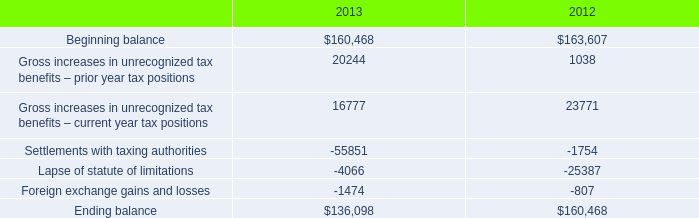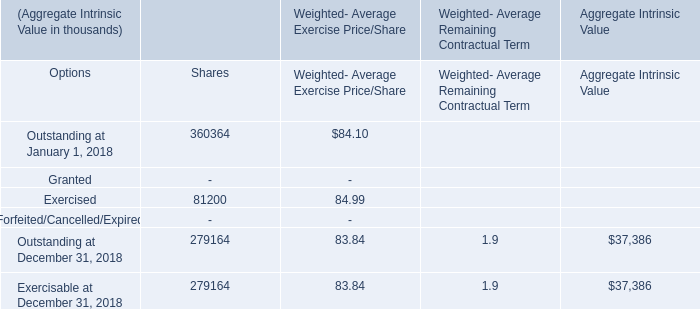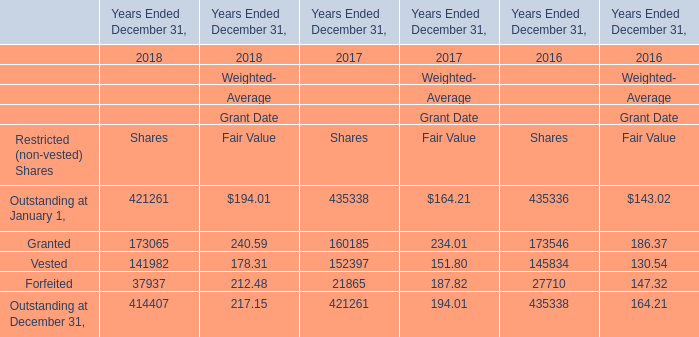What's the current growth rate of Granted for Weighted-Average Grant Date Fair Value? 
Computations: ((240.59 - 234.01) / 234.01)
Answer: 0.02812. 